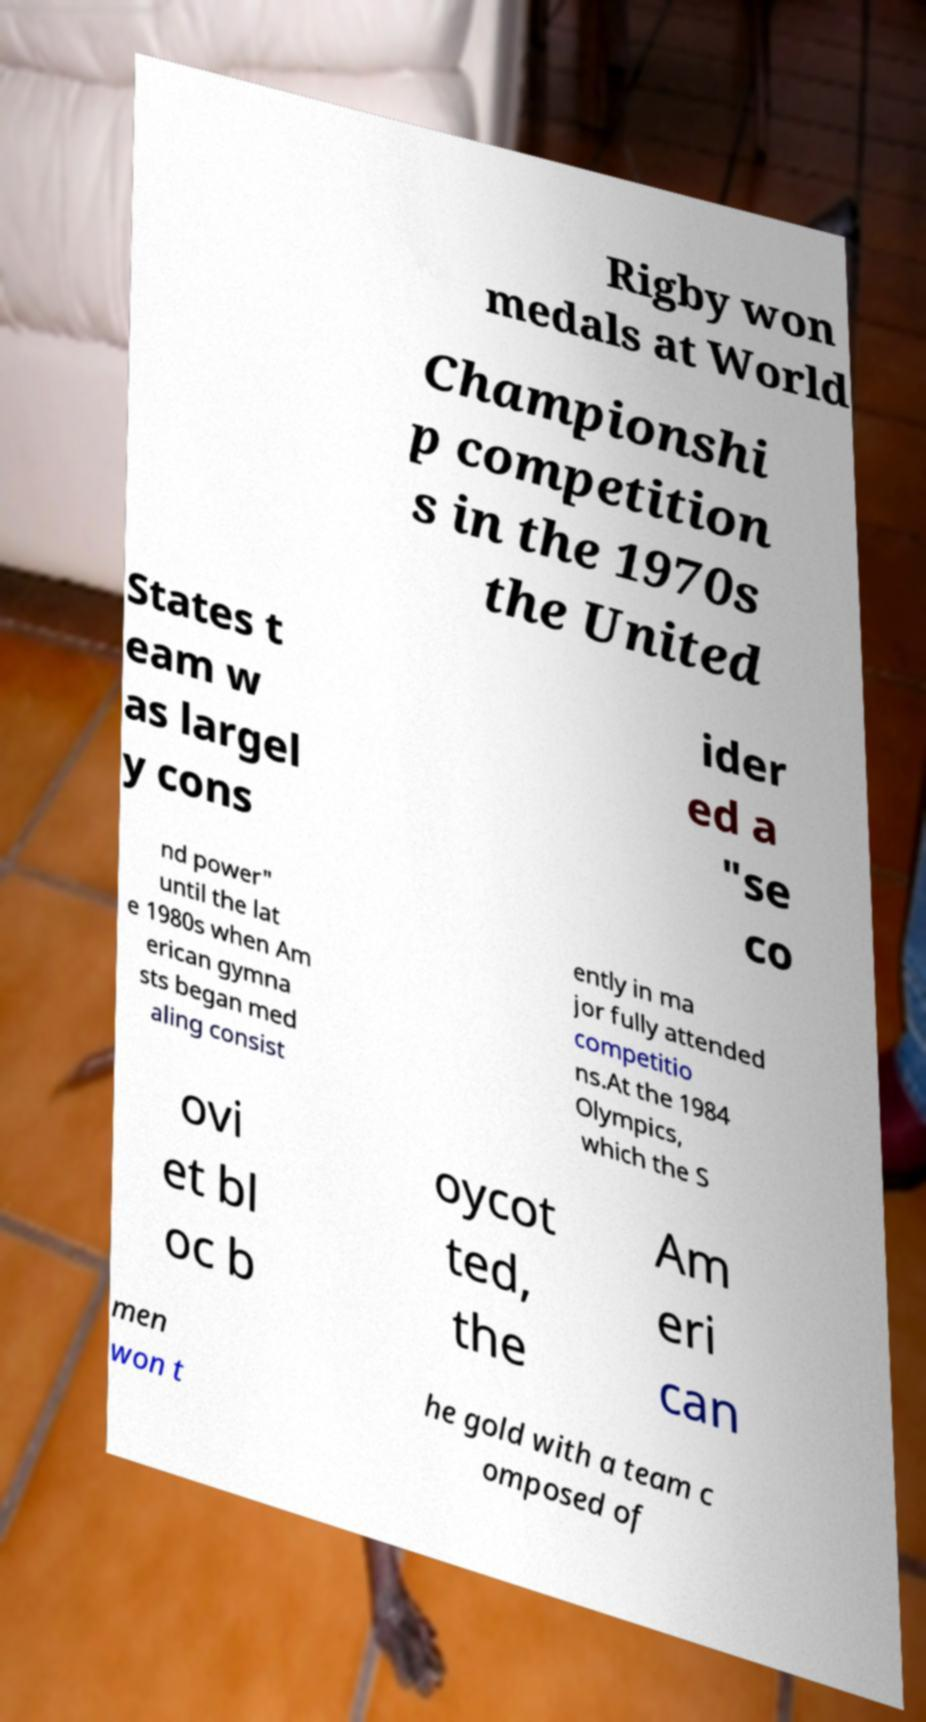For documentation purposes, I need the text within this image transcribed. Could you provide that? Rigby won medals at World Championshi p competition s in the 1970s the United States t eam w as largel y cons ider ed a "se co nd power" until the lat e 1980s when Am erican gymna sts began med aling consist ently in ma jor fully attended competitio ns.At the 1984 Olympics, which the S ovi et bl oc b oycot ted, the Am eri can men won t he gold with a team c omposed of 